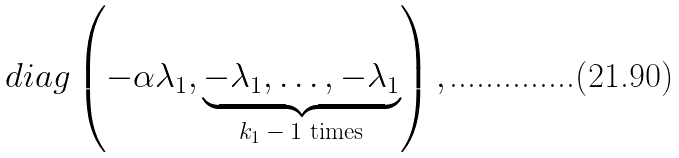Convert formula to latex. <formula><loc_0><loc_0><loc_500><loc_500>d i a g \left ( - \alpha \lambda _ { 1 } , \underbrace { - \lambda _ { 1 } , \dots , - \lambda _ { 1 } } _ { \text {$k_{1}-1$ times} } \right ) ,</formula> 